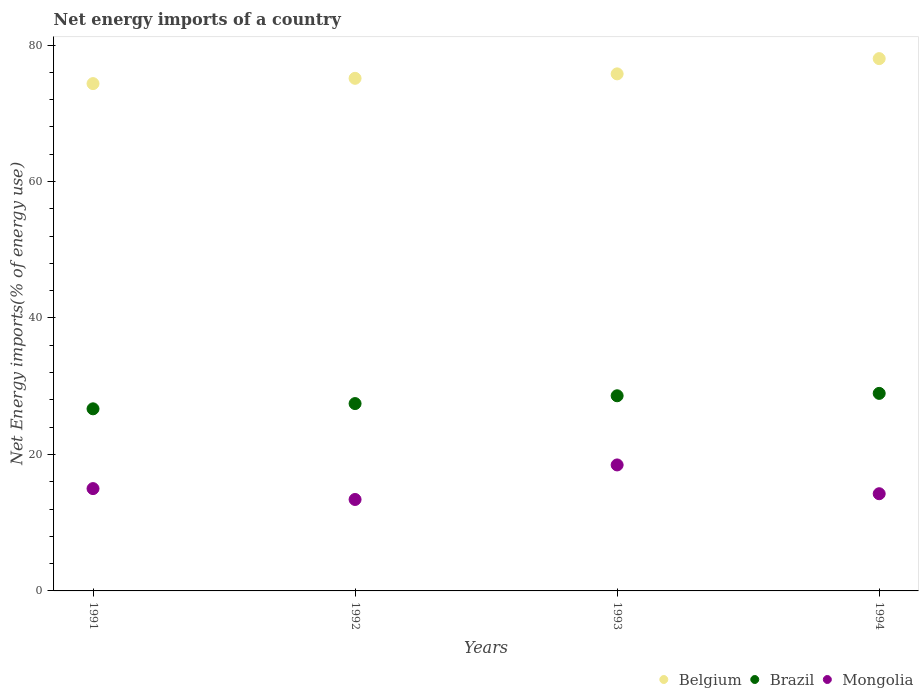How many different coloured dotlines are there?
Provide a succinct answer. 3. Is the number of dotlines equal to the number of legend labels?
Make the answer very short. Yes. What is the net energy imports in Belgium in 1993?
Your response must be concise. 75.78. Across all years, what is the maximum net energy imports in Brazil?
Offer a terse response. 28.95. Across all years, what is the minimum net energy imports in Belgium?
Provide a succinct answer. 74.35. In which year was the net energy imports in Belgium minimum?
Make the answer very short. 1991. What is the total net energy imports in Brazil in the graph?
Your answer should be very brief. 111.7. What is the difference between the net energy imports in Brazil in 1993 and that in 1994?
Offer a terse response. -0.35. What is the difference between the net energy imports in Mongolia in 1991 and the net energy imports in Belgium in 1994?
Make the answer very short. -63.02. What is the average net energy imports in Belgium per year?
Give a very brief answer. 75.82. In the year 1992, what is the difference between the net energy imports in Mongolia and net energy imports in Belgium?
Give a very brief answer. -61.72. In how many years, is the net energy imports in Brazil greater than 4 %?
Your answer should be compact. 4. What is the ratio of the net energy imports in Mongolia in 1991 to that in 1994?
Your answer should be very brief. 1.05. What is the difference between the highest and the second highest net energy imports in Mongolia?
Ensure brevity in your answer.  3.47. What is the difference between the highest and the lowest net energy imports in Belgium?
Ensure brevity in your answer.  3.66. Is the sum of the net energy imports in Brazil in 1993 and 1994 greater than the maximum net energy imports in Belgium across all years?
Your response must be concise. No. Is the net energy imports in Belgium strictly greater than the net energy imports in Brazil over the years?
Provide a succinct answer. Yes. Is the net energy imports in Brazil strictly less than the net energy imports in Belgium over the years?
Your answer should be very brief. Yes. How many dotlines are there?
Keep it short and to the point. 3. How many years are there in the graph?
Offer a very short reply. 4. What is the difference between two consecutive major ticks on the Y-axis?
Give a very brief answer. 20. Are the values on the major ticks of Y-axis written in scientific E-notation?
Provide a short and direct response. No. Does the graph contain any zero values?
Offer a very short reply. No. Does the graph contain grids?
Offer a very short reply. No. Where does the legend appear in the graph?
Your response must be concise. Bottom right. How are the legend labels stacked?
Provide a succinct answer. Horizontal. What is the title of the graph?
Ensure brevity in your answer.  Net energy imports of a country. What is the label or title of the Y-axis?
Your response must be concise. Net Energy imports(% of energy use). What is the Net Energy imports(% of energy use) in Belgium in 1991?
Provide a short and direct response. 74.35. What is the Net Energy imports(% of energy use) in Brazil in 1991?
Ensure brevity in your answer.  26.69. What is the Net Energy imports(% of energy use) in Mongolia in 1991?
Offer a very short reply. 15. What is the Net Energy imports(% of energy use) in Belgium in 1992?
Offer a terse response. 75.13. What is the Net Energy imports(% of energy use) of Brazil in 1992?
Keep it short and to the point. 27.46. What is the Net Energy imports(% of energy use) in Mongolia in 1992?
Your answer should be compact. 13.4. What is the Net Energy imports(% of energy use) of Belgium in 1993?
Make the answer very short. 75.78. What is the Net Energy imports(% of energy use) of Brazil in 1993?
Keep it short and to the point. 28.6. What is the Net Energy imports(% of energy use) in Mongolia in 1993?
Ensure brevity in your answer.  18.46. What is the Net Energy imports(% of energy use) of Belgium in 1994?
Your answer should be very brief. 78.01. What is the Net Energy imports(% of energy use) of Brazil in 1994?
Offer a terse response. 28.95. What is the Net Energy imports(% of energy use) in Mongolia in 1994?
Your response must be concise. 14.24. Across all years, what is the maximum Net Energy imports(% of energy use) of Belgium?
Offer a very short reply. 78.01. Across all years, what is the maximum Net Energy imports(% of energy use) in Brazil?
Provide a succinct answer. 28.95. Across all years, what is the maximum Net Energy imports(% of energy use) in Mongolia?
Your answer should be compact. 18.46. Across all years, what is the minimum Net Energy imports(% of energy use) in Belgium?
Offer a terse response. 74.35. Across all years, what is the minimum Net Energy imports(% of energy use) of Brazil?
Give a very brief answer. 26.69. Across all years, what is the minimum Net Energy imports(% of energy use) in Mongolia?
Offer a very short reply. 13.4. What is the total Net Energy imports(% of energy use) in Belgium in the graph?
Give a very brief answer. 303.27. What is the total Net Energy imports(% of energy use) in Brazil in the graph?
Your answer should be compact. 111.7. What is the total Net Energy imports(% of energy use) of Mongolia in the graph?
Offer a terse response. 61.11. What is the difference between the Net Energy imports(% of energy use) in Belgium in 1991 and that in 1992?
Ensure brevity in your answer.  -0.77. What is the difference between the Net Energy imports(% of energy use) in Brazil in 1991 and that in 1992?
Provide a succinct answer. -0.77. What is the difference between the Net Energy imports(% of energy use) in Mongolia in 1991 and that in 1992?
Ensure brevity in your answer.  1.59. What is the difference between the Net Energy imports(% of energy use) in Belgium in 1991 and that in 1993?
Make the answer very short. -1.43. What is the difference between the Net Energy imports(% of energy use) of Brazil in 1991 and that in 1993?
Offer a terse response. -1.91. What is the difference between the Net Energy imports(% of energy use) in Mongolia in 1991 and that in 1993?
Give a very brief answer. -3.47. What is the difference between the Net Energy imports(% of energy use) of Belgium in 1991 and that in 1994?
Offer a very short reply. -3.66. What is the difference between the Net Energy imports(% of energy use) of Brazil in 1991 and that in 1994?
Give a very brief answer. -2.26. What is the difference between the Net Energy imports(% of energy use) of Mongolia in 1991 and that in 1994?
Your response must be concise. 0.75. What is the difference between the Net Energy imports(% of energy use) of Belgium in 1992 and that in 1993?
Make the answer very short. -0.65. What is the difference between the Net Energy imports(% of energy use) of Brazil in 1992 and that in 1993?
Your answer should be very brief. -1.14. What is the difference between the Net Energy imports(% of energy use) of Mongolia in 1992 and that in 1993?
Make the answer very short. -5.06. What is the difference between the Net Energy imports(% of energy use) in Belgium in 1992 and that in 1994?
Ensure brevity in your answer.  -2.89. What is the difference between the Net Energy imports(% of energy use) in Brazil in 1992 and that in 1994?
Ensure brevity in your answer.  -1.49. What is the difference between the Net Energy imports(% of energy use) in Mongolia in 1992 and that in 1994?
Make the answer very short. -0.84. What is the difference between the Net Energy imports(% of energy use) in Belgium in 1993 and that in 1994?
Your response must be concise. -2.24. What is the difference between the Net Energy imports(% of energy use) of Brazil in 1993 and that in 1994?
Make the answer very short. -0.35. What is the difference between the Net Energy imports(% of energy use) of Mongolia in 1993 and that in 1994?
Ensure brevity in your answer.  4.22. What is the difference between the Net Energy imports(% of energy use) in Belgium in 1991 and the Net Energy imports(% of energy use) in Brazil in 1992?
Your answer should be compact. 46.89. What is the difference between the Net Energy imports(% of energy use) of Belgium in 1991 and the Net Energy imports(% of energy use) of Mongolia in 1992?
Offer a very short reply. 60.95. What is the difference between the Net Energy imports(% of energy use) of Brazil in 1991 and the Net Energy imports(% of energy use) of Mongolia in 1992?
Your response must be concise. 13.29. What is the difference between the Net Energy imports(% of energy use) in Belgium in 1991 and the Net Energy imports(% of energy use) in Brazil in 1993?
Offer a very short reply. 45.75. What is the difference between the Net Energy imports(% of energy use) of Belgium in 1991 and the Net Energy imports(% of energy use) of Mongolia in 1993?
Provide a succinct answer. 55.89. What is the difference between the Net Energy imports(% of energy use) in Brazil in 1991 and the Net Energy imports(% of energy use) in Mongolia in 1993?
Your answer should be very brief. 8.22. What is the difference between the Net Energy imports(% of energy use) in Belgium in 1991 and the Net Energy imports(% of energy use) in Brazil in 1994?
Give a very brief answer. 45.4. What is the difference between the Net Energy imports(% of energy use) in Belgium in 1991 and the Net Energy imports(% of energy use) in Mongolia in 1994?
Offer a very short reply. 60.11. What is the difference between the Net Energy imports(% of energy use) in Brazil in 1991 and the Net Energy imports(% of energy use) in Mongolia in 1994?
Offer a very short reply. 12.44. What is the difference between the Net Energy imports(% of energy use) in Belgium in 1992 and the Net Energy imports(% of energy use) in Brazil in 1993?
Your answer should be compact. 46.53. What is the difference between the Net Energy imports(% of energy use) in Belgium in 1992 and the Net Energy imports(% of energy use) in Mongolia in 1993?
Give a very brief answer. 56.66. What is the difference between the Net Energy imports(% of energy use) in Brazil in 1992 and the Net Energy imports(% of energy use) in Mongolia in 1993?
Make the answer very short. 8.99. What is the difference between the Net Energy imports(% of energy use) in Belgium in 1992 and the Net Energy imports(% of energy use) in Brazil in 1994?
Make the answer very short. 46.17. What is the difference between the Net Energy imports(% of energy use) in Belgium in 1992 and the Net Energy imports(% of energy use) in Mongolia in 1994?
Your answer should be compact. 60.88. What is the difference between the Net Energy imports(% of energy use) of Brazil in 1992 and the Net Energy imports(% of energy use) of Mongolia in 1994?
Your answer should be very brief. 13.21. What is the difference between the Net Energy imports(% of energy use) in Belgium in 1993 and the Net Energy imports(% of energy use) in Brazil in 1994?
Your answer should be very brief. 46.83. What is the difference between the Net Energy imports(% of energy use) in Belgium in 1993 and the Net Energy imports(% of energy use) in Mongolia in 1994?
Keep it short and to the point. 61.53. What is the difference between the Net Energy imports(% of energy use) of Brazil in 1993 and the Net Energy imports(% of energy use) of Mongolia in 1994?
Keep it short and to the point. 14.36. What is the average Net Energy imports(% of energy use) of Belgium per year?
Offer a terse response. 75.82. What is the average Net Energy imports(% of energy use) in Brazil per year?
Provide a short and direct response. 27.92. What is the average Net Energy imports(% of energy use) of Mongolia per year?
Provide a succinct answer. 15.28. In the year 1991, what is the difference between the Net Energy imports(% of energy use) of Belgium and Net Energy imports(% of energy use) of Brazil?
Provide a short and direct response. 47.66. In the year 1991, what is the difference between the Net Energy imports(% of energy use) of Belgium and Net Energy imports(% of energy use) of Mongolia?
Offer a very short reply. 59.36. In the year 1991, what is the difference between the Net Energy imports(% of energy use) in Brazil and Net Energy imports(% of energy use) in Mongolia?
Ensure brevity in your answer.  11.69. In the year 1992, what is the difference between the Net Energy imports(% of energy use) of Belgium and Net Energy imports(% of energy use) of Brazil?
Provide a short and direct response. 47.67. In the year 1992, what is the difference between the Net Energy imports(% of energy use) of Belgium and Net Energy imports(% of energy use) of Mongolia?
Give a very brief answer. 61.72. In the year 1992, what is the difference between the Net Energy imports(% of energy use) of Brazil and Net Energy imports(% of energy use) of Mongolia?
Offer a terse response. 14.05. In the year 1993, what is the difference between the Net Energy imports(% of energy use) of Belgium and Net Energy imports(% of energy use) of Brazil?
Make the answer very short. 47.18. In the year 1993, what is the difference between the Net Energy imports(% of energy use) of Belgium and Net Energy imports(% of energy use) of Mongolia?
Make the answer very short. 57.31. In the year 1993, what is the difference between the Net Energy imports(% of energy use) of Brazil and Net Energy imports(% of energy use) of Mongolia?
Ensure brevity in your answer.  10.14. In the year 1994, what is the difference between the Net Energy imports(% of energy use) of Belgium and Net Energy imports(% of energy use) of Brazil?
Your answer should be compact. 49.06. In the year 1994, what is the difference between the Net Energy imports(% of energy use) in Belgium and Net Energy imports(% of energy use) in Mongolia?
Your answer should be compact. 63.77. In the year 1994, what is the difference between the Net Energy imports(% of energy use) of Brazil and Net Energy imports(% of energy use) of Mongolia?
Offer a very short reply. 14.71. What is the ratio of the Net Energy imports(% of energy use) of Mongolia in 1991 to that in 1992?
Your answer should be compact. 1.12. What is the ratio of the Net Energy imports(% of energy use) in Belgium in 1991 to that in 1993?
Your answer should be compact. 0.98. What is the ratio of the Net Energy imports(% of energy use) of Brazil in 1991 to that in 1993?
Offer a terse response. 0.93. What is the ratio of the Net Energy imports(% of energy use) of Mongolia in 1991 to that in 1993?
Provide a succinct answer. 0.81. What is the ratio of the Net Energy imports(% of energy use) in Belgium in 1991 to that in 1994?
Provide a succinct answer. 0.95. What is the ratio of the Net Energy imports(% of energy use) in Brazil in 1991 to that in 1994?
Your answer should be compact. 0.92. What is the ratio of the Net Energy imports(% of energy use) in Mongolia in 1991 to that in 1994?
Provide a short and direct response. 1.05. What is the ratio of the Net Energy imports(% of energy use) in Belgium in 1992 to that in 1993?
Offer a terse response. 0.99. What is the ratio of the Net Energy imports(% of energy use) of Brazil in 1992 to that in 1993?
Your response must be concise. 0.96. What is the ratio of the Net Energy imports(% of energy use) of Mongolia in 1992 to that in 1993?
Your answer should be very brief. 0.73. What is the ratio of the Net Energy imports(% of energy use) in Brazil in 1992 to that in 1994?
Offer a terse response. 0.95. What is the ratio of the Net Energy imports(% of energy use) of Mongolia in 1992 to that in 1994?
Ensure brevity in your answer.  0.94. What is the ratio of the Net Energy imports(% of energy use) of Belgium in 1993 to that in 1994?
Provide a short and direct response. 0.97. What is the ratio of the Net Energy imports(% of energy use) in Brazil in 1993 to that in 1994?
Provide a short and direct response. 0.99. What is the ratio of the Net Energy imports(% of energy use) of Mongolia in 1993 to that in 1994?
Offer a very short reply. 1.3. What is the difference between the highest and the second highest Net Energy imports(% of energy use) of Belgium?
Your response must be concise. 2.24. What is the difference between the highest and the second highest Net Energy imports(% of energy use) in Brazil?
Offer a very short reply. 0.35. What is the difference between the highest and the second highest Net Energy imports(% of energy use) in Mongolia?
Your answer should be very brief. 3.47. What is the difference between the highest and the lowest Net Energy imports(% of energy use) in Belgium?
Your answer should be very brief. 3.66. What is the difference between the highest and the lowest Net Energy imports(% of energy use) of Brazil?
Your response must be concise. 2.26. What is the difference between the highest and the lowest Net Energy imports(% of energy use) of Mongolia?
Your response must be concise. 5.06. 